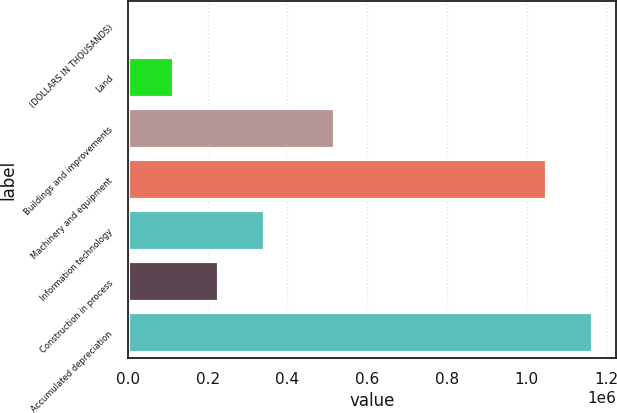Convert chart. <chart><loc_0><loc_0><loc_500><loc_500><bar_chart><fcel>(DOLLARS IN THOUSANDS)<fcel>Land<fcel>Buildings and improvements<fcel>Machinery and equipment<fcel>Information technology<fcel>Construction in process<fcel>Accumulated depreciation<nl><fcel>2016<fcel>115576<fcel>519947<fcel>1.05211e+06<fcel>342696<fcel>229136<fcel>1.16567e+06<nl></chart> 